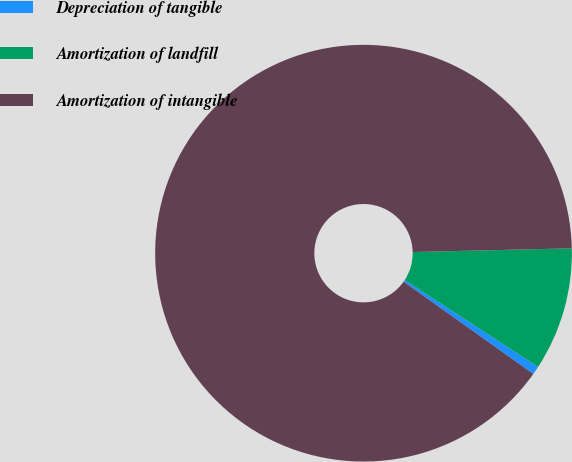Convert chart to OTSL. <chart><loc_0><loc_0><loc_500><loc_500><pie_chart><fcel>Depreciation of tangible<fcel>Amortization of landfill<fcel>Amortization of intangible<nl><fcel>0.65%<fcel>9.56%<fcel>89.79%<nl></chart> 